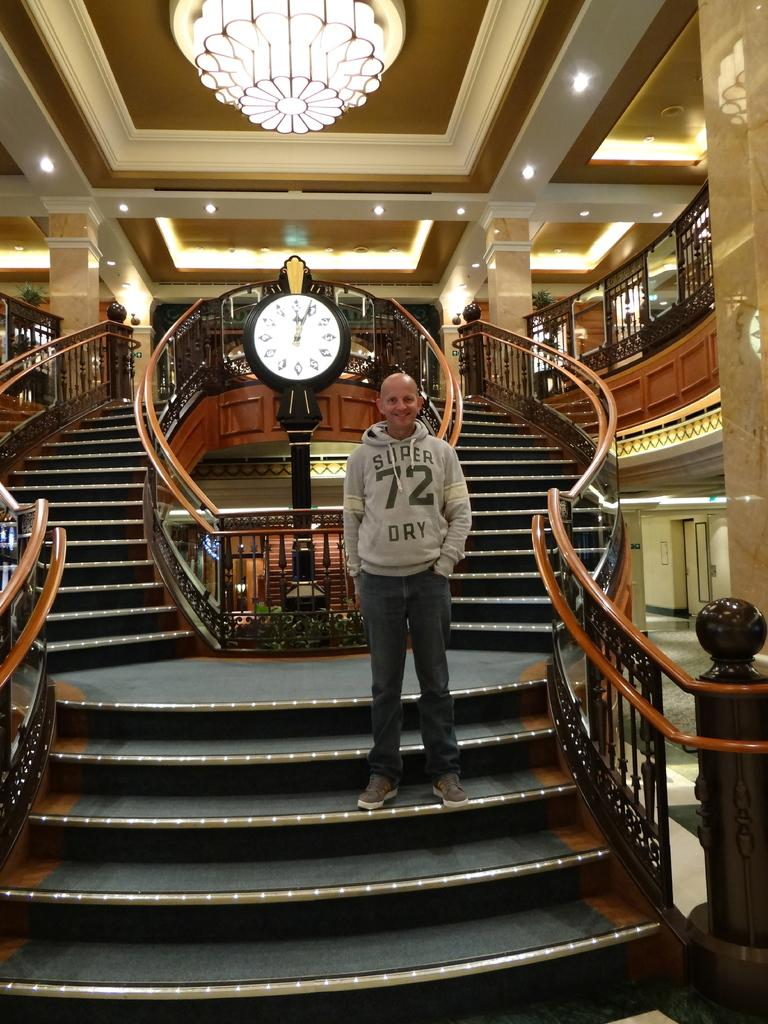<image>
Offer a succinct explanation of the picture presented. A man stands wearing a Super Dry hoodie on some steps in front of a clock. 